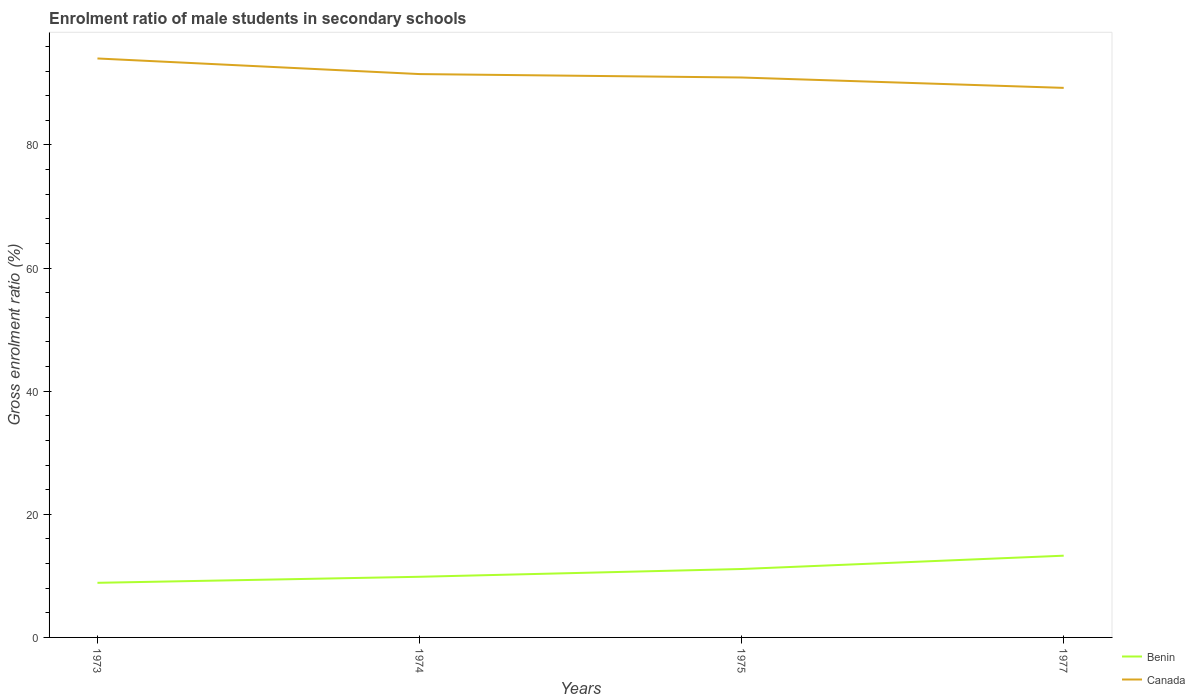How many different coloured lines are there?
Your answer should be compact. 2. Across all years, what is the maximum enrolment ratio of male students in secondary schools in Benin?
Provide a succinct answer. 8.87. What is the total enrolment ratio of male students in secondary schools in Benin in the graph?
Keep it short and to the point. -1.26. What is the difference between the highest and the second highest enrolment ratio of male students in secondary schools in Canada?
Provide a succinct answer. 4.78. What is the difference between the highest and the lowest enrolment ratio of male students in secondary schools in Canada?
Your answer should be compact. 2. Is the enrolment ratio of male students in secondary schools in Canada strictly greater than the enrolment ratio of male students in secondary schools in Benin over the years?
Your answer should be compact. No. How many years are there in the graph?
Offer a very short reply. 4. Does the graph contain any zero values?
Ensure brevity in your answer.  No. Does the graph contain grids?
Make the answer very short. No. Where does the legend appear in the graph?
Keep it short and to the point. Bottom right. How are the legend labels stacked?
Provide a succinct answer. Vertical. What is the title of the graph?
Your response must be concise. Enrolment ratio of male students in secondary schools. Does "Chile" appear as one of the legend labels in the graph?
Offer a terse response. No. What is the Gross enrolment ratio (%) in Benin in 1973?
Your answer should be compact. 8.87. What is the Gross enrolment ratio (%) of Canada in 1973?
Offer a terse response. 94.04. What is the Gross enrolment ratio (%) in Benin in 1974?
Keep it short and to the point. 9.85. What is the Gross enrolment ratio (%) in Canada in 1974?
Offer a very short reply. 91.51. What is the Gross enrolment ratio (%) of Benin in 1975?
Provide a succinct answer. 11.11. What is the Gross enrolment ratio (%) in Canada in 1975?
Make the answer very short. 90.95. What is the Gross enrolment ratio (%) in Benin in 1977?
Ensure brevity in your answer.  13.28. What is the Gross enrolment ratio (%) in Canada in 1977?
Make the answer very short. 89.27. Across all years, what is the maximum Gross enrolment ratio (%) of Benin?
Your response must be concise. 13.28. Across all years, what is the maximum Gross enrolment ratio (%) of Canada?
Your response must be concise. 94.04. Across all years, what is the minimum Gross enrolment ratio (%) of Benin?
Make the answer very short. 8.87. Across all years, what is the minimum Gross enrolment ratio (%) of Canada?
Keep it short and to the point. 89.27. What is the total Gross enrolment ratio (%) of Benin in the graph?
Provide a short and direct response. 43.11. What is the total Gross enrolment ratio (%) in Canada in the graph?
Ensure brevity in your answer.  365.77. What is the difference between the Gross enrolment ratio (%) in Benin in 1973 and that in 1974?
Ensure brevity in your answer.  -0.98. What is the difference between the Gross enrolment ratio (%) of Canada in 1973 and that in 1974?
Your answer should be compact. 2.54. What is the difference between the Gross enrolment ratio (%) of Benin in 1973 and that in 1975?
Offer a terse response. -2.24. What is the difference between the Gross enrolment ratio (%) in Canada in 1973 and that in 1975?
Ensure brevity in your answer.  3.09. What is the difference between the Gross enrolment ratio (%) of Benin in 1973 and that in 1977?
Your response must be concise. -4.41. What is the difference between the Gross enrolment ratio (%) in Canada in 1973 and that in 1977?
Offer a very short reply. 4.78. What is the difference between the Gross enrolment ratio (%) of Benin in 1974 and that in 1975?
Your answer should be compact. -1.26. What is the difference between the Gross enrolment ratio (%) in Canada in 1974 and that in 1975?
Your answer should be very brief. 0.56. What is the difference between the Gross enrolment ratio (%) of Benin in 1974 and that in 1977?
Provide a short and direct response. -3.42. What is the difference between the Gross enrolment ratio (%) in Canada in 1974 and that in 1977?
Make the answer very short. 2.24. What is the difference between the Gross enrolment ratio (%) of Benin in 1975 and that in 1977?
Give a very brief answer. -2.16. What is the difference between the Gross enrolment ratio (%) in Canada in 1975 and that in 1977?
Keep it short and to the point. 1.68. What is the difference between the Gross enrolment ratio (%) in Benin in 1973 and the Gross enrolment ratio (%) in Canada in 1974?
Make the answer very short. -82.64. What is the difference between the Gross enrolment ratio (%) of Benin in 1973 and the Gross enrolment ratio (%) of Canada in 1975?
Your response must be concise. -82.08. What is the difference between the Gross enrolment ratio (%) of Benin in 1973 and the Gross enrolment ratio (%) of Canada in 1977?
Your response must be concise. -80.4. What is the difference between the Gross enrolment ratio (%) in Benin in 1974 and the Gross enrolment ratio (%) in Canada in 1975?
Offer a very short reply. -81.1. What is the difference between the Gross enrolment ratio (%) in Benin in 1974 and the Gross enrolment ratio (%) in Canada in 1977?
Offer a very short reply. -79.42. What is the difference between the Gross enrolment ratio (%) in Benin in 1975 and the Gross enrolment ratio (%) in Canada in 1977?
Your answer should be very brief. -78.15. What is the average Gross enrolment ratio (%) in Benin per year?
Your answer should be compact. 10.78. What is the average Gross enrolment ratio (%) in Canada per year?
Offer a very short reply. 91.44. In the year 1973, what is the difference between the Gross enrolment ratio (%) in Benin and Gross enrolment ratio (%) in Canada?
Ensure brevity in your answer.  -85.17. In the year 1974, what is the difference between the Gross enrolment ratio (%) of Benin and Gross enrolment ratio (%) of Canada?
Offer a very short reply. -81.66. In the year 1975, what is the difference between the Gross enrolment ratio (%) in Benin and Gross enrolment ratio (%) in Canada?
Give a very brief answer. -79.84. In the year 1977, what is the difference between the Gross enrolment ratio (%) in Benin and Gross enrolment ratio (%) in Canada?
Offer a very short reply. -75.99. What is the ratio of the Gross enrolment ratio (%) of Benin in 1973 to that in 1974?
Ensure brevity in your answer.  0.9. What is the ratio of the Gross enrolment ratio (%) of Canada in 1973 to that in 1974?
Your answer should be very brief. 1.03. What is the ratio of the Gross enrolment ratio (%) of Benin in 1973 to that in 1975?
Ensure brevity in your answer.  0.8. What is the ratio of the Gross enrolment ratio (%) in Canada in 1973 to that in 1975?
Provide a succinct answer. 1.03. What is the ratio of the Gross enrolment ratio (%) of Benin in 1973 to that in 1977?
Offer a terse response. 0.67. What is the ratio of the Gross enrolment ratio (%) of Canada in 1973 to that in 1977?
Your answer should be very brief. 1.05. What is the ratio of the Gross enrolment ratio (%) in Benin in 1974 to that in 1975?
Provide a succinct answer. 0.89. What is the ratio of the Gross enrolment ratio (%) in Benin in 1974 to that in 1977?
Ensure brevity in your answer.  0.74. What is the ratio of the Gross enrolment ratio (%) in Canada in 1974 to that in 1977?
Provide a short and direct response. 1.03. What is the ratio of the Gross enrolment ratio (%) of Benin in 1975 to that in 1977?
Your answer should be very brief. 0.84. What is the ratio of the Gross enrolment ratio (%) in Canada in 1975 to that in 1977?
Provide a succinct answer. 1.02. What is the difference between the highest and the second highest Gross enrolment ratio (%) of Benin?
Your answer should be compact. 2.16. What is the difference between the highest and the second highest Gross enrolment ratio (%) in Canada?
Make the answer very short. 2.54. What is the difference between the highest and the lowest Gross enrolment ratio (%) in Benin?
Offer a terse response. 4.41. What is the difference between the highest and the lowest Gross enrolment ratio (%) of Canada?
Provide a succinct answer. 4.78. 